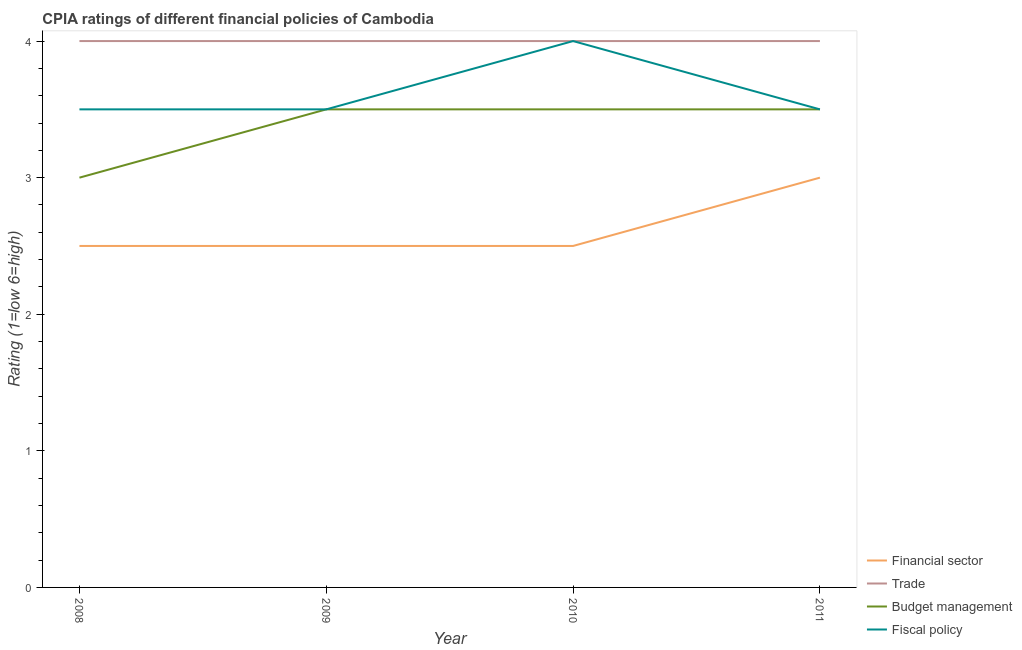What is the cpia rating of fiscal policy in 2009?
Give a very brief answer. 3.5. Across all years, what is the maximum cpia rating of financial sector?
Offer a very short reply. 3. Across all years, what is the minimum cpia rating of trade?
Your answer should be compact. 4. In which year was the cpia rating of budget management minimum?
Make the answer very short. 2008. What is the difference between the cpia rating of fiscal policy in 2009 and that in 2010?
Make the answer very short. -0.5. What is the difference between the cpia rating of budget management in 2011 and the cpia rating of trade in 2008?
Your response must be concise. -0.5. In how many years, is the cpia rating of trade greater than 3.8?
Provide a succinct answer. 4. What is the ratio of the cpia rating of financial sector in 2008 to that in 2011?
Your response must be concise. 0.83. Is the cpia rating of trade in 2010 less than that in 2011?
Offer a terse response. No. What is the difference between the highest and the second highest cpia rating of budget management?
Your answer should be very brief. 0. In how many years, is the cpia rating of budget management greater than the average cpia rating of budget management taken over all years?
Your answer should be very brief. 3. Is the sum of the cpia rating of budget management in 2010 and 2011 greater than the maximum cpia rating of financial sector across all years?
Make the answer very short. Yes. Is it the case that in every year, the sum of the cpia rating of financial sector and cpia rating of trade is greater than the cpia rating of budget management?
Give a very brief answer. Yes. Does the cpia rating of fiscal policy monotonically increase over the years?
Provide a succinct answer. No. How many years are there in the graph?
Your answer should be compact. 4. Are the values on the major ticks of Y-axis written in scientific E-notation?
Provide a short and direct response. No. Does the graph contain any zero values?
Provide a succinct answer. No. Where does the legend appear in the graph?
Your answer should be compact. Bottom right. How are the legend labels stacked?
Your answer should be compact. Vertical. What is the title of the graph?
Ensure brevity in your answer.  CPIA ratings of different financial policies of Cambodia. What is the Rating (1=low 6=high) of Financial sector in 2008?
Offer a very short reply. 2.5. What is the Rating (1=low 6=high) of Budget management in 2008?
Your answer should be compact. 3. What is the Rating (1=low 6=high) of Budget management in 2009?
Your response must be concise. 3.5. What is the Rating (1=low 6=high) of Fiscal policy in 2009?
Offer a terse response. 3.5. What is the Rating (1=low 6=high) in Budget management in 2010?
Provide a succinct answer. 3.5. What is the Rating (1=low 6=high) in Financial sector in 2011?
Provide a short and direct response. 3. What is the Rating (1=low 6=high) in Fiscal policy in 2011?
Provide a short and direct response. 3.5. Across all years, what is the maximum Rating (1=low 6=high) in Financial sector?
Make the answer very short. 3. Across all years, what is the maximum Rating (1=low 6=high) in Budget management?
Provide a succinct answer. 3.5. Across all years, what is the minimum Rating (1=low 6=high) in Financial sector?
Provide a succinct answer. 2.5. Across all years, what is the minimum Rating (1=low 6=high) in Trade?
Ensure brevity in your answer.  4. Across all years, what is the minimum Rating (1=low 6=high) in Budget management?
Your response must be concise. 3. What is the total Rating (1=low 6=high) in Budget management in the graph?
Offer a terse response. 13.5. What is the total Rating (1=low 6=high) of Fiscal policy in the graph?
Provide a succinct answer. 14.5. What is the difference between the Rating (1=low 6=high) of Financial sector in 2008 and that in 2009?
Your response must be concise. 0. What is the difference between the Rating (1=low 6=high) in Budget management in 2008 and that in 2009?
Your response must be concise. -0.5. What is the difference between the Rating (1=low 6=high) in Fiscal policy in 2008 and that in 2009?
Your response must be concise. 0. What is the difference between the Rating (1=low 6=high) in Budget management in 2008 and that in 2010?
Provide a succinct answer. -0.5. What is the difference between the Rating (1=low 6=high) in Trade in 2008 and that in 2011?
Make the answer very short. 0. What is the difference between the Rating (1=low 6=high) of Budget management in 2008 and that in 2011?
Your answer should be compact. -0.5. What is the difference between the Rating (1=low 6=high) of Fiscal policy in 2008 and that in 2011?
Keep it short and to the point. 0. What is the difference between the Rating (1=low 6=high) in Financial sector in 2009 and that in 2010?
Your answer should be compact. 0. What is the difference between the Rating (1=low 6=high) in Trade in 2009 and that in 2010?
Provide a short and direct response. 0. What is the difference between the Rating (1=low 6=high) of Fiscal policy in 2009 and that in 2010?
Offer a terse response. -0.5. What is the difference between the Rating (1=low 6=high) in Budget management in 2009 and that in 2011?
Give a very brief answer. 0. What is the difference between the Rating (1=low 6=high) in Financial sector in 2010 and that in 2011?
Provide a short and direct response. -0.5. What is the difference between the Rating (1=low 6=high) in Budget management in 2010 and that in 2011?
Provide a short and direct response. 0. What is the difference between the Rating (1=low 6=high) of Financial sector in 2008 and the Rating (1=low 6=high) of Trade in 2009?
Your answer should be compact. -1.5. What is the difference between the Rating (1=low 6=high) of Financial sector in 2008 and the Rating (1=low 6=high) of Budget management in 2010?
Provide a succinct answer. -1. What is the difference between the Rating (1=low 6=high) of Financial sector in 2008 and the Rating (1=low 6=high) of Fiscal policy in 2011?
Provide a short and direct response. -1. What is the difference between the Rating (1=low 6=high) of Trade in 2008 and the Rating (1=low 6=high) of Budget management in 2011?
Your answer should be compact. 0.5. What is the difference between the Rating (1=low 6=high) of Budget management in 2008 and the Rating (1=low 6=high) of Fiscal policy in 2011?
Provide a succinct answer. -0.5. What is the difference between the Rating (1=low 6=high) in Financial sector in 2009 and the Rating (1=low 6=high) in Fiscal policy in 2010?
Provide a short and direct response. -1.5. What is the difference between the Rating (1=low 6=high) in Trade in 2009 and the Rating (1=low 6=high) in Budget management in 2010?
Make the answer very short. 0.5. What is the difference between the Rating (1=low 6=high) of Trade in 2009 and the Rating (1=low 6=high) of Fiscal policy in 2010?
Keep it short and to the point. 0. What is the difference between the Rating (1=low 6=high) of Budget management in 2009 and the Rating (1=low 6=high) of Fiscal policy in 2010?
Give a very brief answer. -0.5. What is the difference between the Rating (1=low 6=high) in Financial sector in 2009 and the Rating (1=low 6=high) in Trade in 2011?
Give a very brief answer. -1.5. What is the difference between the Rating (1=low 6=high) of Trade in 2009 and the Rating (1=low 6=high) of Budget management in 2011?
Keep it short and to the point. 0.5. What is the difference between the Rating (1=low 6=high) of Budget management in 2009 and the Rating (1=low 6=high) of Fiscal policy in 2011?
Your answer should be compact. 0. What is the difference between the Rating (1=low 6=high) in Financial sector in 2010 and the Rating (1=low 6=high) in Trade in 2011?
Your response must be concise. -1.5. What is the difference between the Rating (1=low 6=high) of Trade in 2010 and the Rating (1=low 6=high) of Budget management in 2011?
Provide a succinct answer. 0.5. What is the difference between the Rating (1=low 6=high) of Trade in 2010 and the Rating (1=low 6=high) of Fiscal policy in 2011?
Your answer should be compact. 0.5. What is the average Rating (1=low 6=high) of Financial sector per year?
Provide a succinct answer. 2.62. What is the average Rating (1=low 6=high) of Trade per year?
Your answer should be compact. 4. What is the average Rating (1=low 6=high) in Budget management per year?
Ensure brevity in your answer.  3.38. What is the average Rating (1=low 6=high) in Fiscal policy per year?
Provide a succinct answer. 3.62. In the year 2008, what is the difference between the Rating (1=low 6=high) of Financial sector and Rating (1=low 6=high) of Trade?
Your answer should be compact. -1.5. In the year 2008, what is the difference between the Rating (1=low 6=high) of Financial sector and Rating (1=low 6=high) of Fiscal policy?
Your response must be concise. -1. In the year 2009, what is the difference between the Rating (1=low 6=high) in Financial sector and Rating (1=low 6=high) in Fiscal policy?
Provide a succinct answer. -1. In the year 2009, what is the difference between the Rating (1=low 6=high) of Budget management and Rating (1=low 6=high) of Fiscal policy?
Give a very brief answer. 0. In the year 2010, what is the difference between the Rating (1=low 6=high) of Financial sector and Rating (1=low 6=high) of Fiscal policy?
Your answer should be compact. -1.5. In the year 2010, what is the difference between the Rating (1=low 6=high) in Budget management and Rating (1=low 6=high) in Fiscal policy?
Ensure brevity in your answer.  -0.5. In the year 2011, what is the difference between the Rating (1=low 6=high) in Financial sector and Rating (1=low 6=high) in Budget management?
Your answer should be compact. -0.5. In the year 2011, what is the difference between the Rating (1=low 6=high) in Trade and Rating (1=low 6=high) in Budget management?
Offer a very short reply. 0.5. In the year 2011, what is the difference between the Rating (1=low 6=high) of Trade and Rating (1=low 6=high) of Fiscal policy?
Give a very brief answer. 0.5. What is the ratio of the Rating (1=low 6=high) of Trade in 2008 to that in 2009?
Your answer should be very brief. 1. What is the ratio of the Rating (1=low 6=high) of Budget management in 2008 to that in 2009?
Ensure brevity in your answer.  0.86. What is the ratio of the Rating (1=low 6=high) in Budget management in 2008 to that in 2010?
Make the answer very short. 0.86. What is the ratio of the Rating (1=low 6=high) in Financial sector in 2008 to that in 2011?
Keep it short and to the point. 0.83. What is the ratio of the Rating (1=low 6=high) of Trade in 2008 to that in 2011?
Keep it short and to the point. 1. What is the ratio of the Rating (1=low 6=high) in Budget management in 2008 to that in 2011?
Your response must be concise. 0.86. What is the ratio of the Rating (1=low 6=high) of Budget management in 2009 to that in 2010?
Give a very brief answer. 1. What is the ratio of the Rating (1=low 6=high) in Fiscal policy in 2009 to that in 2010?
Provide a succinct answer. 0.88. What is the ratio of the Rating (1=low 6=high) of Fiscal policy in 2009 to that in 2011?
Your response must be concise. 1. What is the ratio of the Rating (1=low 6=high) in Financial sector in 2010 to that in 2011?
Give a very brief answer. 0.83. What is the ratio of the Rating (1=low 6=high) of Trade in 2010 to that in 2011?
Give a very brief answer. 1. What is the difference between the highest and the second highest Rating (1=low 6=high) of Fiscal policy?
Offer a terse response. 0.5. What is the difference between the highest and the lowest Rating (1=low 6=high) of Financial sector?
Offer a very short reply. 0.5. What is the difference between the highest and the lowest Rating (1=low 6=high) of Budget management?
Offer a very short reply. 0.5. What is the difference between the highest and the lowest Rating (1=low 6=high) in Fiscal policy?
Offer a very short reply. 0.5. 